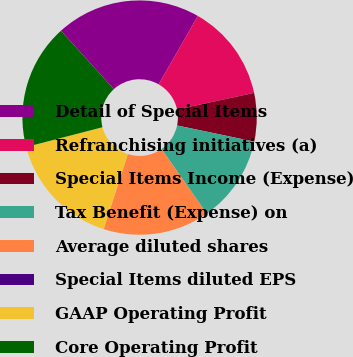Convert chart to OTSL. <chart><loc_0><loc_0><loc_500><loc_500><pie_chart><fcel>Detail of Special Items<fcel>Refranchising initiatives (a)<fcel>Special Items Income (Expense)<fcel>Tax Benefit (Expense) on<fcel>Average diluted shares<fcel>Special Items diluted EPS<fcel>GAAP Operating Profit<fcel>Core Operating Profit<nl><fcel>20.0%<fcel>13.33%<fcel>6.67%<fcel>12.0%<fcel>14.67%<fcel>0.0%<fcel>16.0%<fcel>17.33%<nl></chart> 